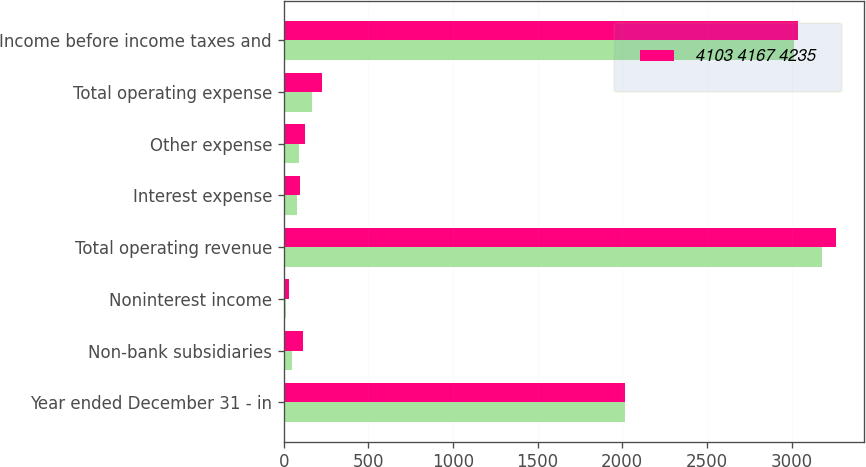Convert chart. <chart><loc_0><loc_0><loc_500><loc_500><stacked_bar_chart><ecel><fcel>Year ended December 31 - in<fcel>Non-bank subsidiaries<fcel>Noninterest income<fcel>Total operating revenue<fcel>Interest expense<fcel>Other expense<fcel>Total operating expense<fcel>Income before income taxes and<nl><fcel>nan<fcel>2015<fcel>49<fcel>14<fcel>3178<fcel>78<fcel>88<fcel>166<fcel>3012<nl><fcel>4103 4167 4235<fcel>2014<fcel>115<fcel>30<fcel>3264<fcel>97<fcel>127<fcel>224<fcel>3040<nl></chart> 